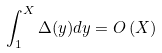Convert formula to latex. <formula><loc_0><loc_0><loc_500><loc_500>\int _ { 1 } ^ { X } \Delta ( y ) d y & = O \left ( X \right )</formula> 